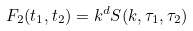<formula> <loc_0><loc_0><loc_500><loc_500>F _ { 2 } ( t _ { 1 } , t _ { 2 } ) = k ^ { d } S ( k , \tau _ { 1 } , \tau _ { 2 } )</formula> 